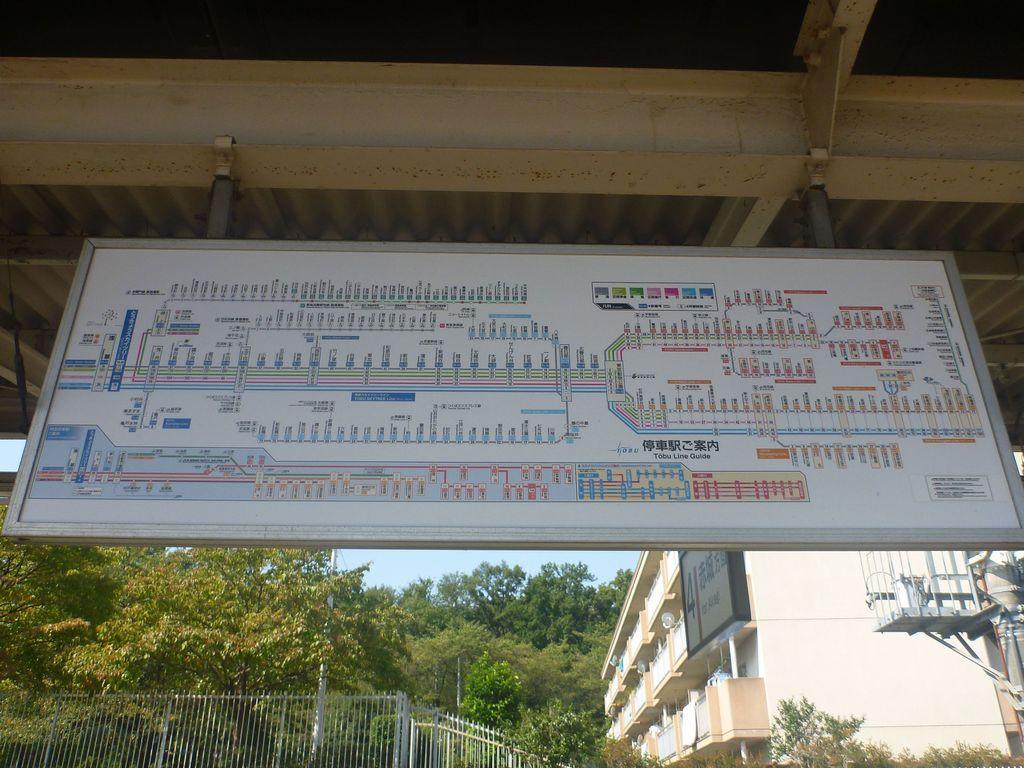Can you describe this image briefly? In this image I see a board on which there is a map and in the background I see the fencing over here and I see the building and I see number of trees and I see the blue sky. 